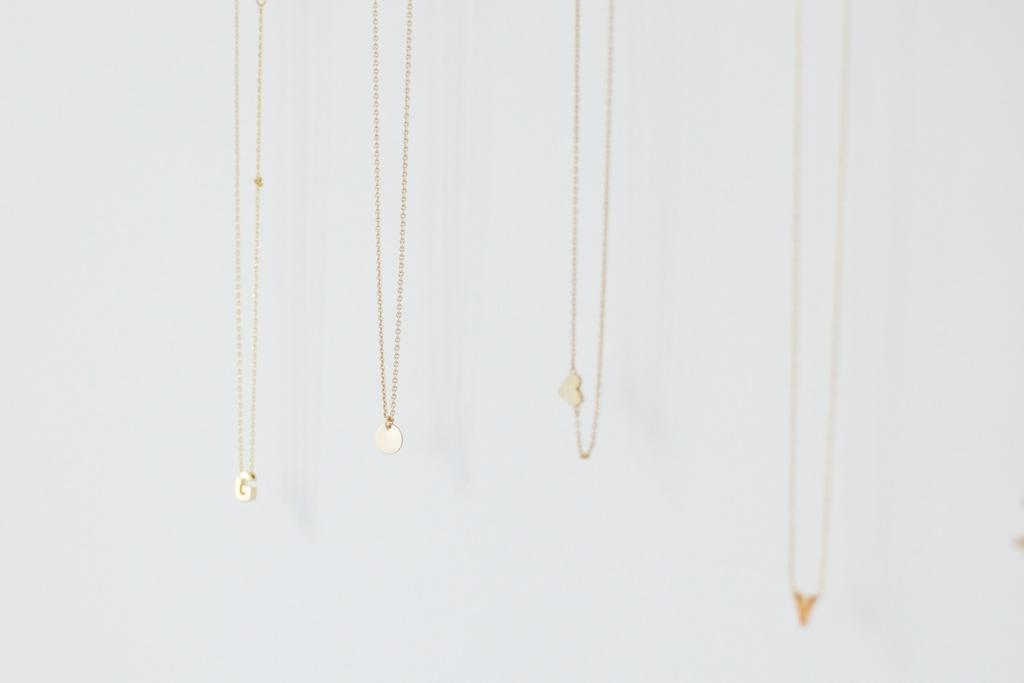What objects are hanging in the image? There are four chains with pendants in the image. What color is the background of the image? The background of the image is white. How many cherries are on the roll in the image? There is no roll or cherries present in the image. 